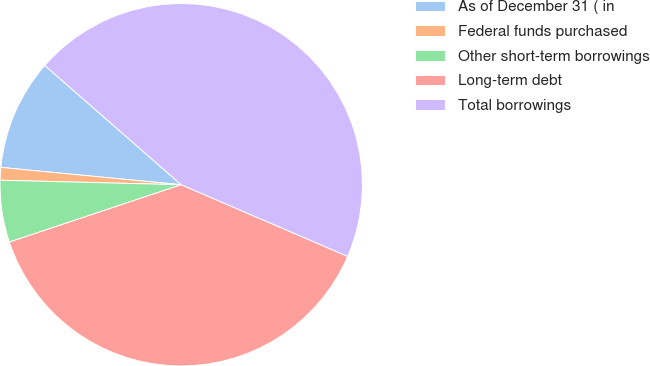<chart> <loc_0><loc_0><loc_500><loc_500><pie_chart><fcel>As of December 31 ( in<fcel>Federal funds purchased<fcel>Other short-term borrowings<fcel>Long-term debt<fcel>Total borrowings<nl><fcel>9.91%<fcel>1.13%<fcel>5.52%<fcel>38.4%<fcel>45.03%<nl></chart> 